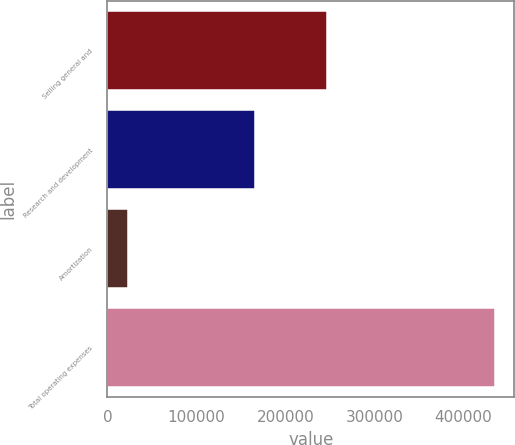<chart> <loc_0><loc_0><loc_500><loc_500><bar_chart><fcel>Selling general and<fcel>Research and development<fcel>Amortization<fcel>Total operating expenses<nl><fcel>246376<fcel>165421<fcel>23388<fcel>435185<nl></chart> 